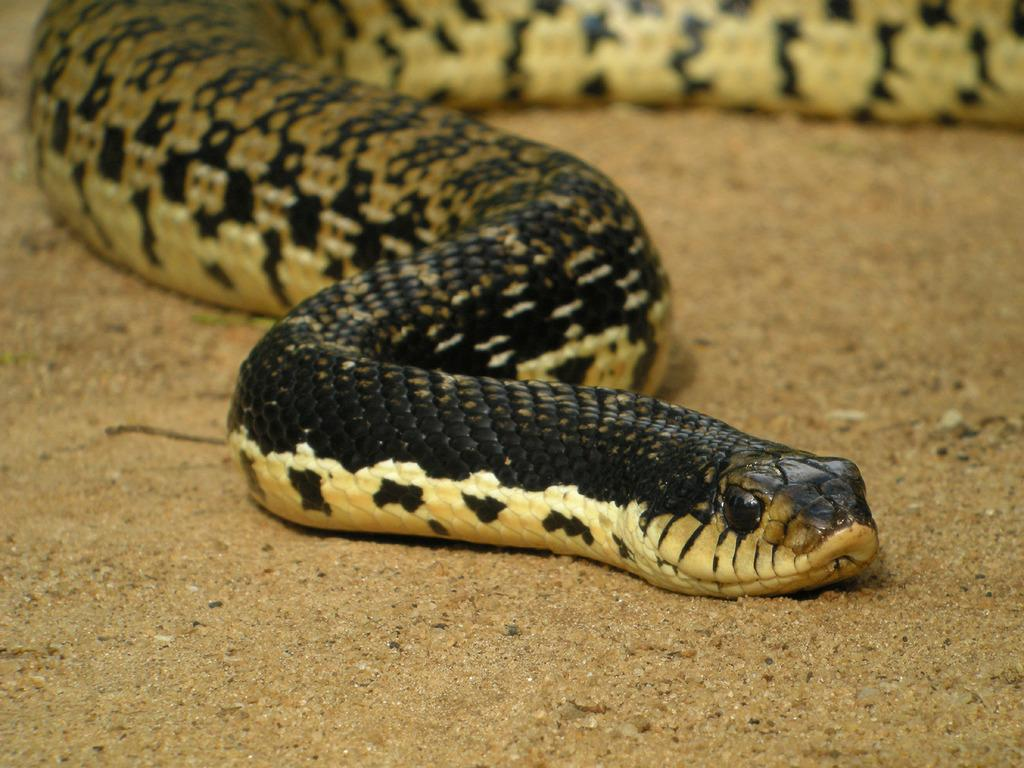What is the color of the ground in the image? The ground in the image is brown in color. What type of animal can be seen in the image? There is a snake in the image. What colors make up the snake's appearance? The snake is cream, black, and brown in color. How many cherries are on the baseball bat in the image? There are no cherries or baseball bat present in the image. 